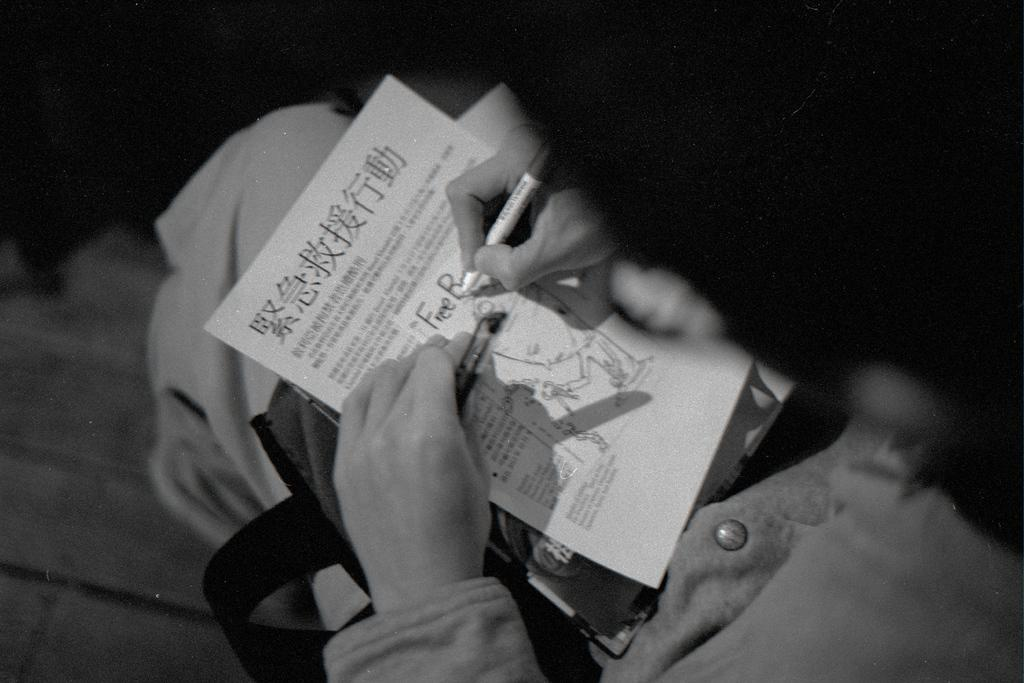What type of picture is in the image? The image contains a black and white picture. What is the person in the picture doing? The person is sitting and holding a paper and a pen in their hands. What color is the background of the black and white picture? The background of the black and white picture is black in color. How many hills can be seen in the background of the image? There are no hills visible in the image; it contains a black and white picture with a black background. 